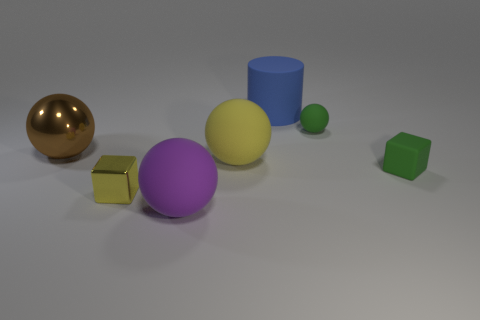Subtract all red cubes. Subtract all blue spheres. How many cubes are left? 2 Add 1 shiny blocks. How many objects exist? 8 Subtract all cubes. How many objects are left? 5 Add 1 green rubber balls. How many green rubber balls are left? 2 Add 1 small yellow shiny objects. How many small yellow shiny objects exist? 2 Subtract 0 green cylinders. How many objects are left? 7 Subtract all green matte spheres. Subtract all large blue cylinders. How many objects are left? 5 